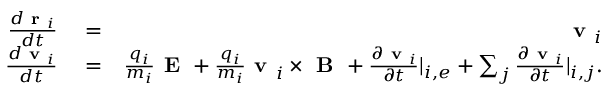Convert formula to latex. <formula><loc_0><loc_0><loc_500><loc_500>\begin{array} { r l r } { \frac { d r _ { i } } { d t } } & = } & { v _ { i } } \\ { \frac { d v _ { i } } { d t } } & = } & { \frac { q _ { i } } { m _ { i } } E + \frac { q _ { i } } { m _ { i } } v _ { i } \times B + \frac { \partial v _ { i } } { \partial t } | _ { i , e } + \sum _ { j } \frac { \partial v _ { i } } { \partial t } | _ { i , j } . } \end{array}</formula> 